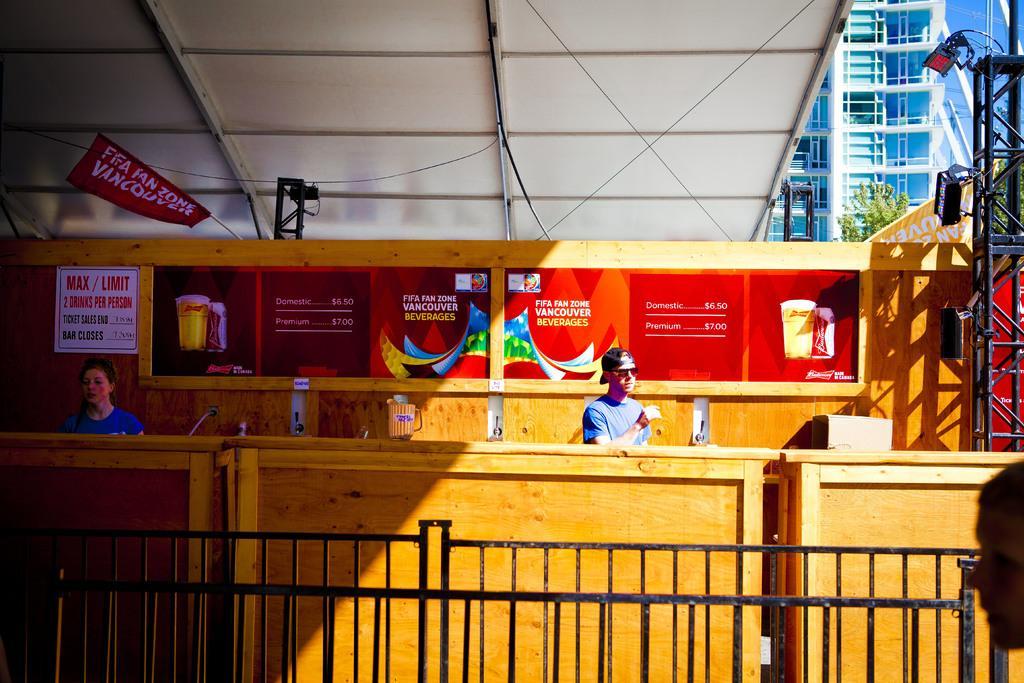How would you summarize this image in a sentence or two? In this picture I can see there is a wooden desk and there is a woman and a man standing. They are wearing blue shirts, there is a beer glass placed on the desk. In the backdrop there are banners and there is a iron frame onto right, there are lights attached to it and there is a railing here in front of the desk. There is a tree and a building in the backdrop. 